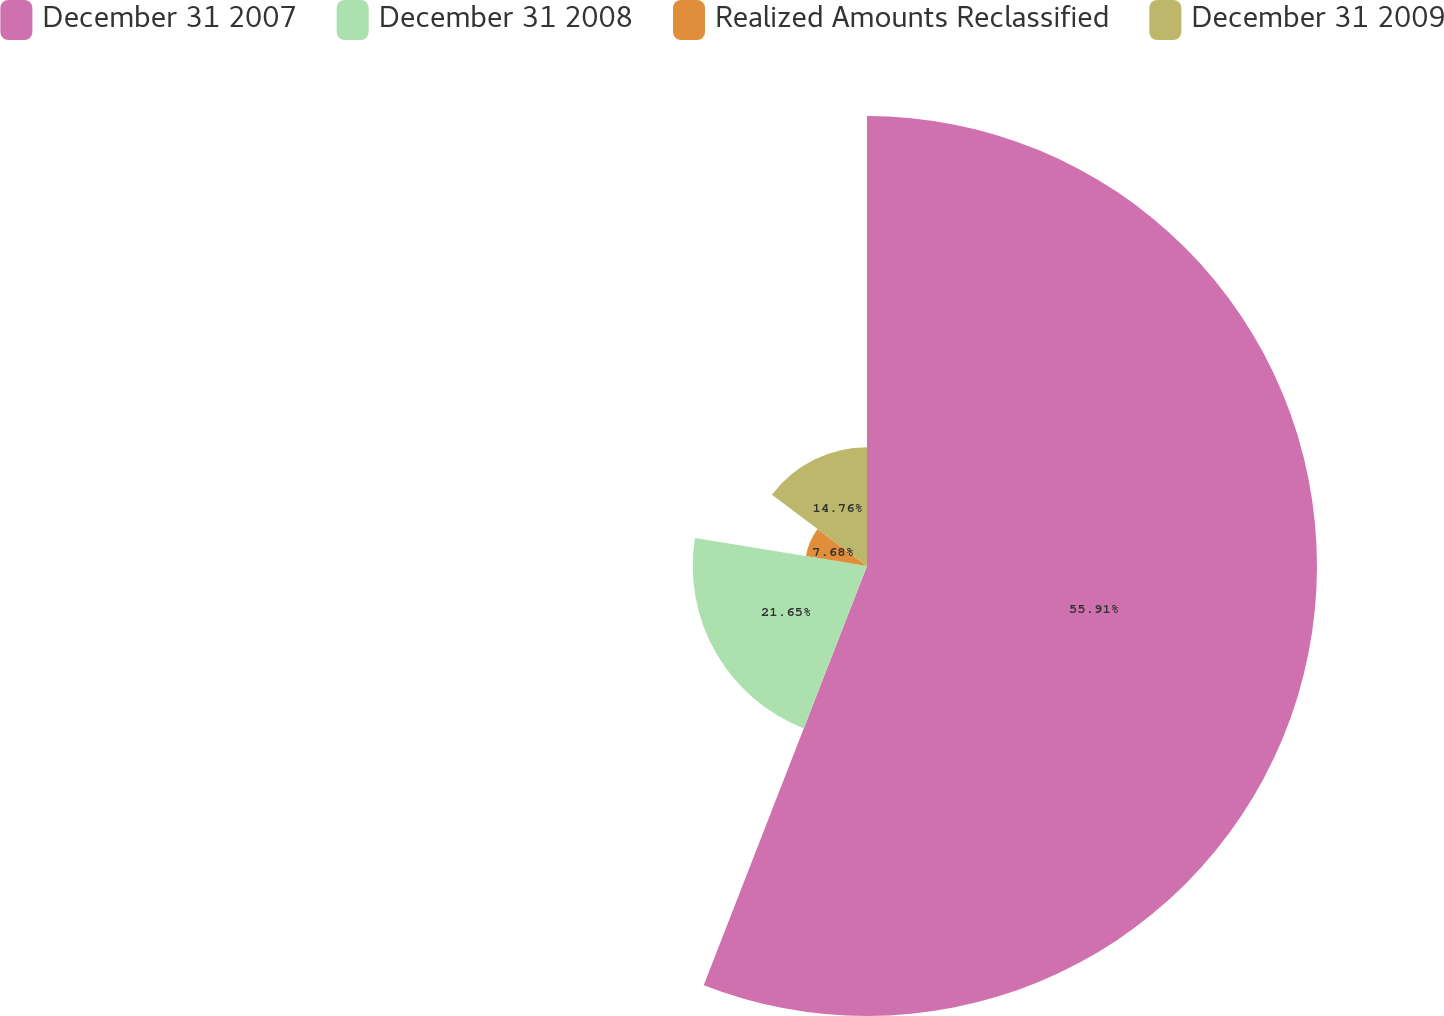<chart> <loc_0><loc_0><loc_500><loc_500><pie_chart><fcel>December 31 2007<fcel>December 31 2008<fcel>Realized Amounts Reclassified<fcel>December 31 2009<nl><fcel>55.91%<fcel>21.65%<fcel>7.68%<fcel>14.76%<nl></chart> 